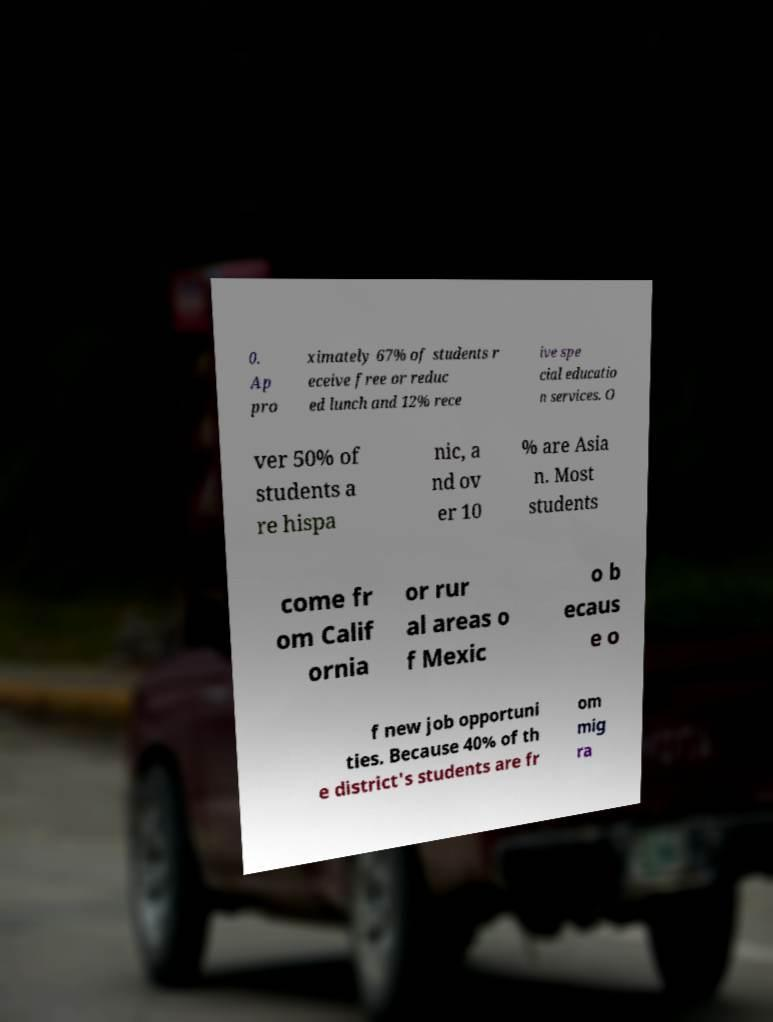What messages or text are displayed in this image? I need them in a readable, typed format. 0. Ap pro ximately 67% of students r eceive free or reduc ed lunch and 12% rece ive spe cial educatio n services. O ver 50% of students a re hispa nic, a nd ov er 10 % are Asia n. Most students come fr om Calif ornia or rur al areas o f Mexic o b ecaus e o f new job opportuni ties. Because 40% of th e district's students are fr om mig ra 